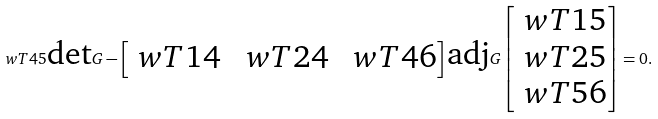Convert formula to latex. <formula><loc_0><loc_0><loc_500><loc_500>\ w T { 4 5 } \text {det} G - \begin{bmatrix} \ w T { 1 4 } & \ w T { 2 4 } & \ w T { 4 6 } \\ \end{bmatrix} \text {adj} G \begin{bmatrix} \ w T { 1 5 } \\ \ w T { 2 5 } \\ \ w T { 5 6 } \\ \end{bmatrix} = 0 .</formula> 